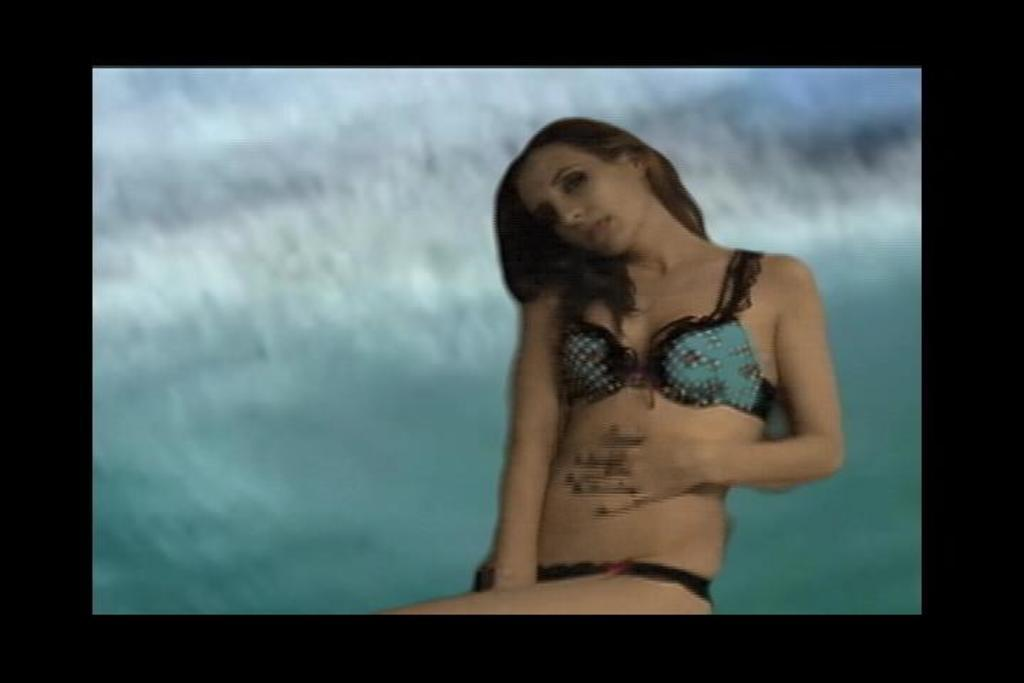Who is the main subject in the image? There is a woman in the image. Can you describe the background of the image? The background of the image is blurred. What type of test can be seen being conducted in the image? There is no test present in the image; it features a woman with a blurred background. 